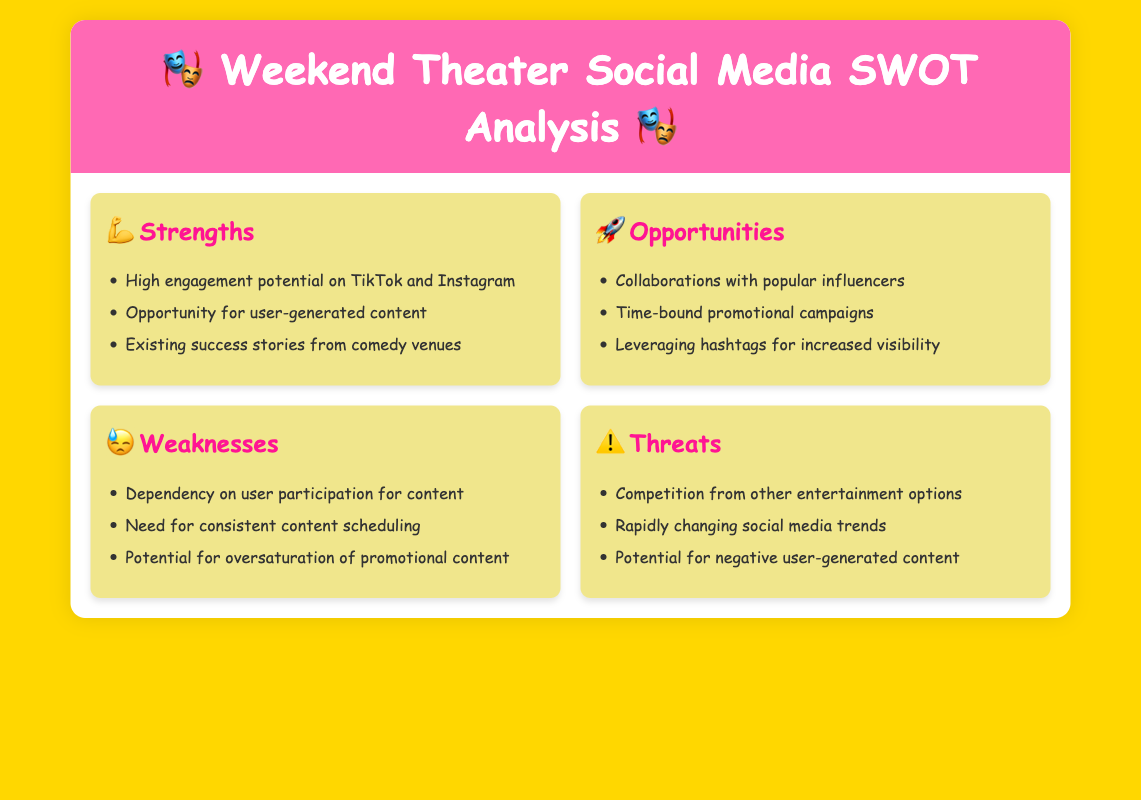What is the main topic of the document? The main topic is about social media strategies specifically for promoting weekend theater visits.
Answer: Weekend Theater Social Media SWOT Analysis How many strengths are listed in the SWOT analysis? There are three strengths mentioned in the analysis.
Answer: 3 What social media platforms are highlighted for high engagement potential? The platforms highlighted are TikTok and Instagram, known for their high engagement potential.
Answer: TikTok and Instagram What is one opportunity mentioned for promoting theater visits? One opportunity is collaborating with popular influencers to promote theater visits effectively.
Answer: Collaborations with popular influencers What is the first weakness noted in the analysis? The first weakness listed is dependency on user participation for content.
Answer: Dependency on user participation for content How many threats are identified in the SWOT analysis? There are three threats identified in the analysis.
Answer: 3 What type of content can be leveraged for increased visibility? Hashtags are mentioned as a way to increase visibility for the promoting content.
Answer: Hashtags What is a potential result of oversaturation mentioned in the weaknesses? A potential result of oversaturation could lead to reduced effectiveness of promotional content.
Answer: Oversaturation of promotional content 